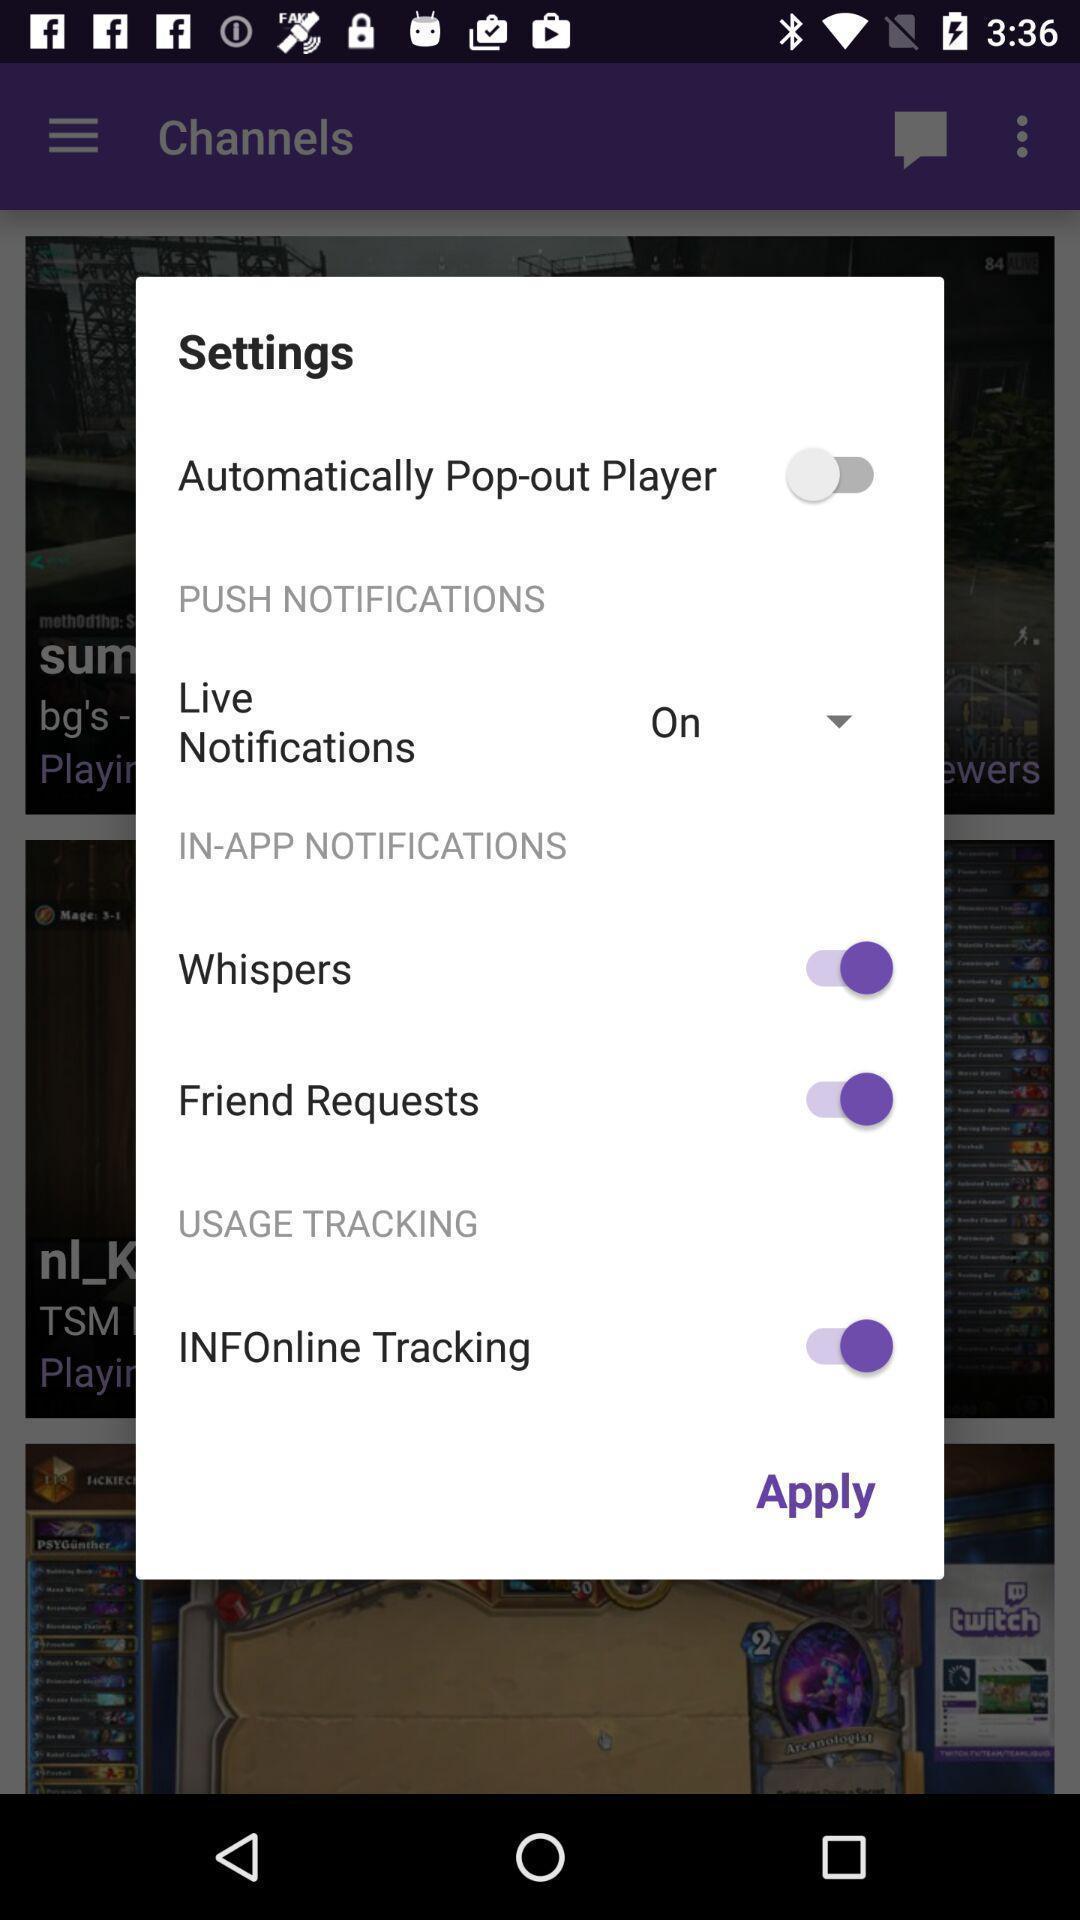Tell me about the visual elements in this screen capture. Pop-up to apply the pop-up settings. 